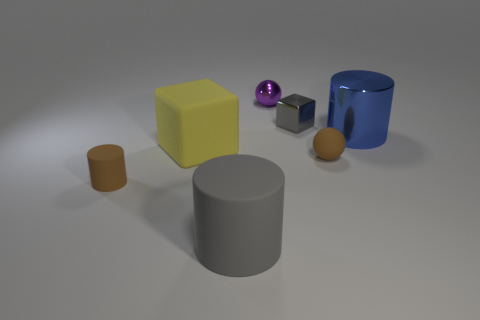Can you describe the lighting and atmosphere of the scene? The scene has a soft, diffused lighting that casts gentle shadows, creating a calm and neutral atmosphere. The shades of gray in the background and the matte surface beneath the objects suggest a studio setting with controlled lighting. The light source seems to be positioned above the objects, possibly simulating an overcast sky or a softbox light diffuser in a photo studio. 